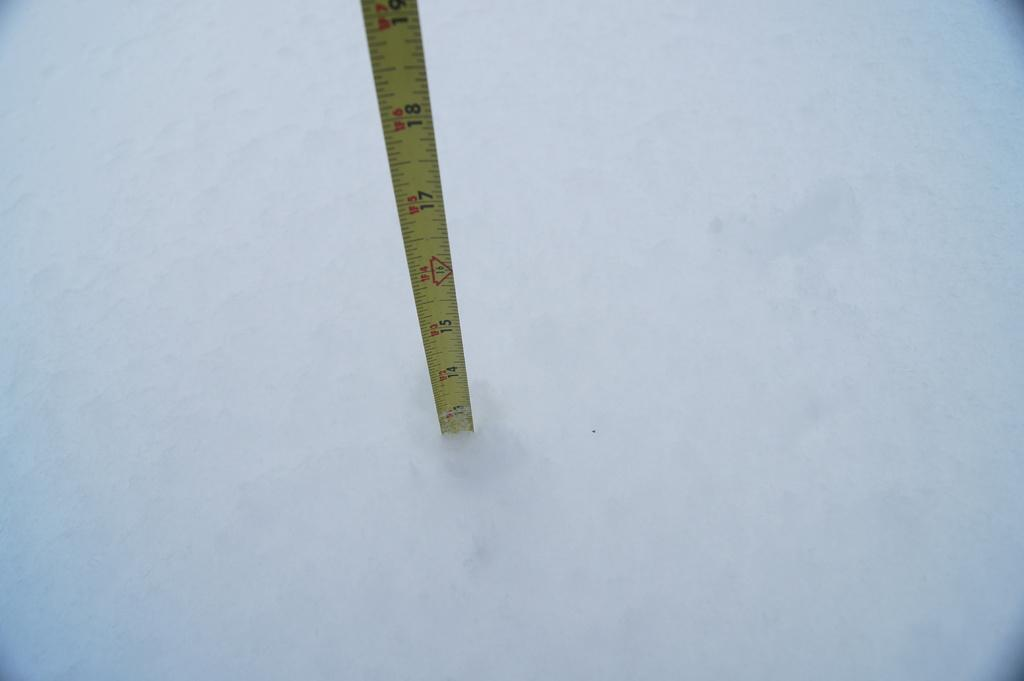What is the color of the object in the image? The object in the image is white in color. What tool is present in the image? There is a measuring tape in the image. What colors make up the measuring tape? The measuring tape is yellow, red, and black in color. How is the measuring tape being used in the image? The measuring tape is inserted into the white colored object. Reasoning: Let'g: Let's think step by step in order to produce the conversation. We start by identifying the color of the main object in the image, which is white. Then, we mention the presence of a measuring tape and describe its colors. Finally, we explain how the measuring tape is being used in the image, which is by inserting it into the white object. Absurd Question/Answer: What type of observation can be made about the comfort of the white object in the image? There is no information about the comfort of the white object in the image, as it only shows the object and the measuring tape. 